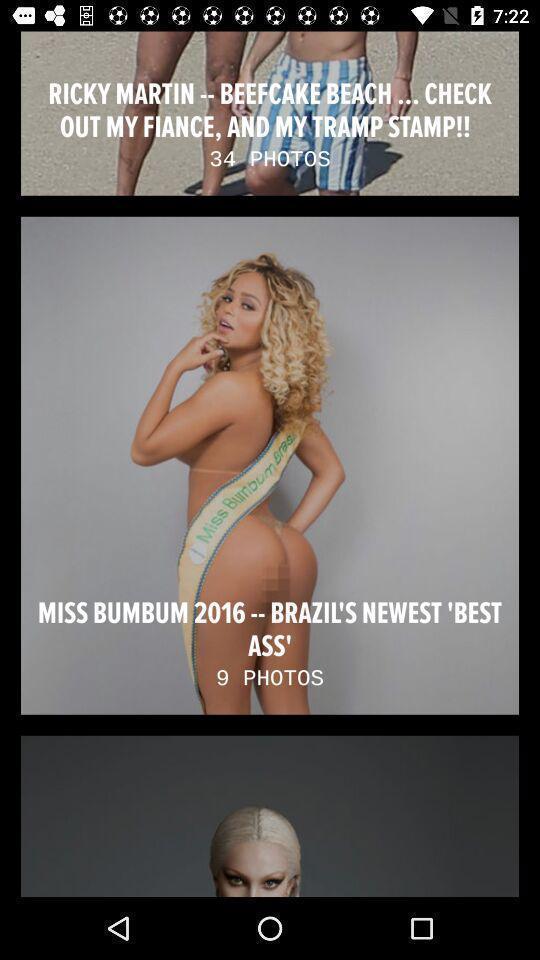Please provide a description for this image. Photos of people. 